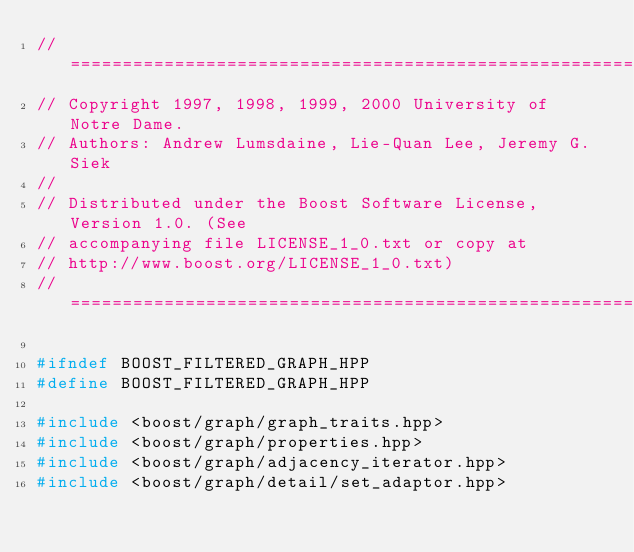<code> <loc_0><loc_0><loc_500><loc_500><_C++_>//=======================================================================
// Copyright 1997, 1998, 1999, 2000 University of Notre Dame.
// Authors: Andrew Lumsdaine, Lie-Quan Lee, Jeremy G. Siek
//
// Distributed under the Boost Software License, Version 1.0. (See
// accompanying file LICENSE_1_0.txt or copy at
// http://www.boost.org/LICENSE_1_0.txt)
//=======================================================================

#ifndef BOOST_FILTERED_GRAPH_HPP
#define BOOST_FILTERED_GRAPH_HPP

#include <boost/graph/graph_traits.hpp>
#include <boost/graph/properties.hpp>
#include <boost/graph/adjacency_iterator.hpp>
#include <boost/graph/detail/set_adaptor.hpp></code> 